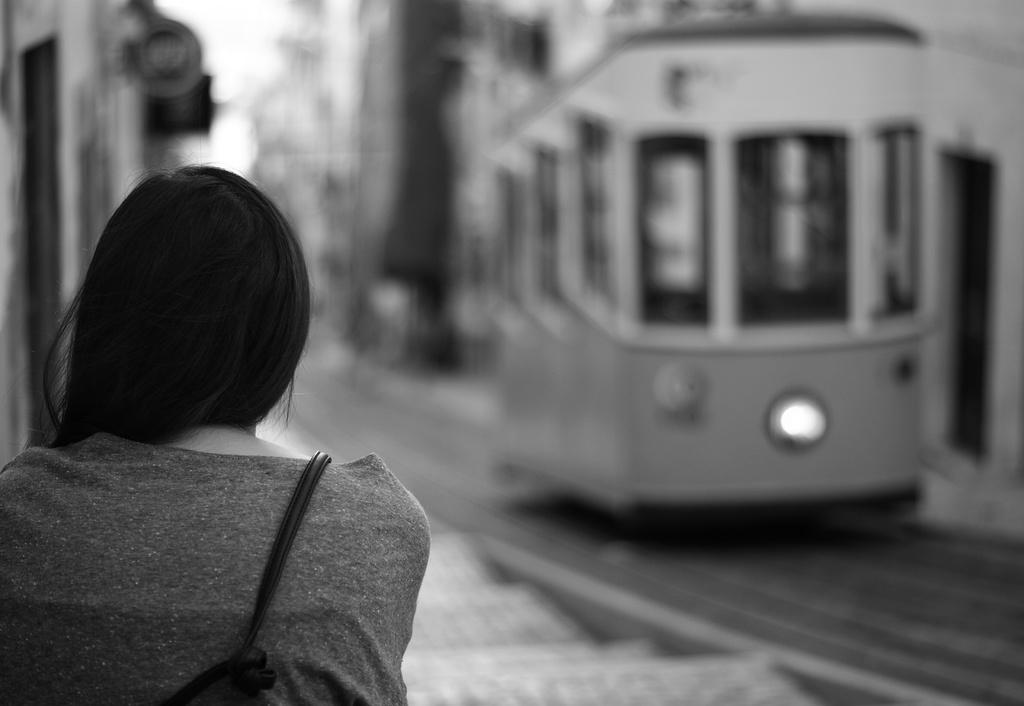What is the color scheme of the image? The image is black and white. Who is the main subject in the foreground of the image? There is a lady in the foreground of the image. What can be seen in the background of the image? There are buildings in the background of the image. What mode of transportation is present in the image? There is a train in the image. What type of wine is being served by the maid in the image}? There is no maid or wine present in the image. 